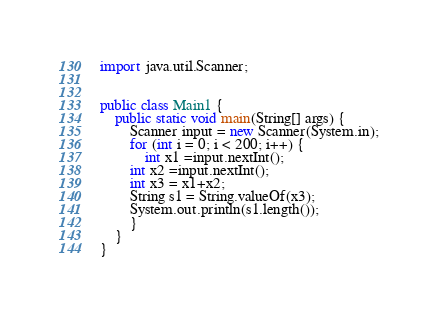<code> <loc_0><loc_0><loc_500><loc_500><_Java_>
import java.util.Scanner;


public class Main1 {
    public static void main(String[] args) {
        Scanner input = new Scanner(System.in);
        for (int i = 0; i < 200; i++) {
            int x1 =input.nextInt();
        int x2 =input.nextInt();
        int x3 = x1+x2;
        String s1 = String.valueOf(x3);
        System.out.println(s1.length());
        }
    }
}</code> 